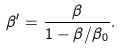<formula> <loc_0><loc_0><loc_500><loc_500>\beta ^ { \prime } = \frac { \beta } { 1 - \beta / \beta _ { 0 } } .</formula> 